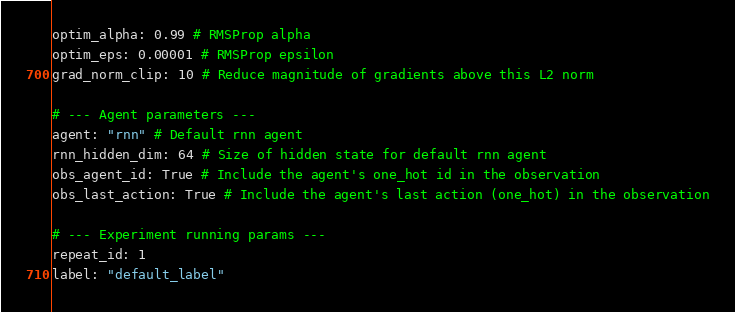Convert code to text. <code><loc_0><loc_0><loc_500><loc_500><_YAML_>optim_alpha: 0.99 # RMSProp alpha
optim_eps: 0.00001 # RMSProp epsilon
grad_norm_clip: 10 # Reduce magnitude of gradients above this L2 norm

# --- Agent parameters ---
agent: "rnn" # Default rnn agent
rnn_hidden_dim: 64 # Size of hidden state for default rnn agent
obs_agent_id: True # Include the agent's one_hot id in the observation
obs_last_action: True # Include the agent's last action (one_hot) in the observation

# --- Experiment running params ---
repeat_id: 1
label: "default_label"
</code> 